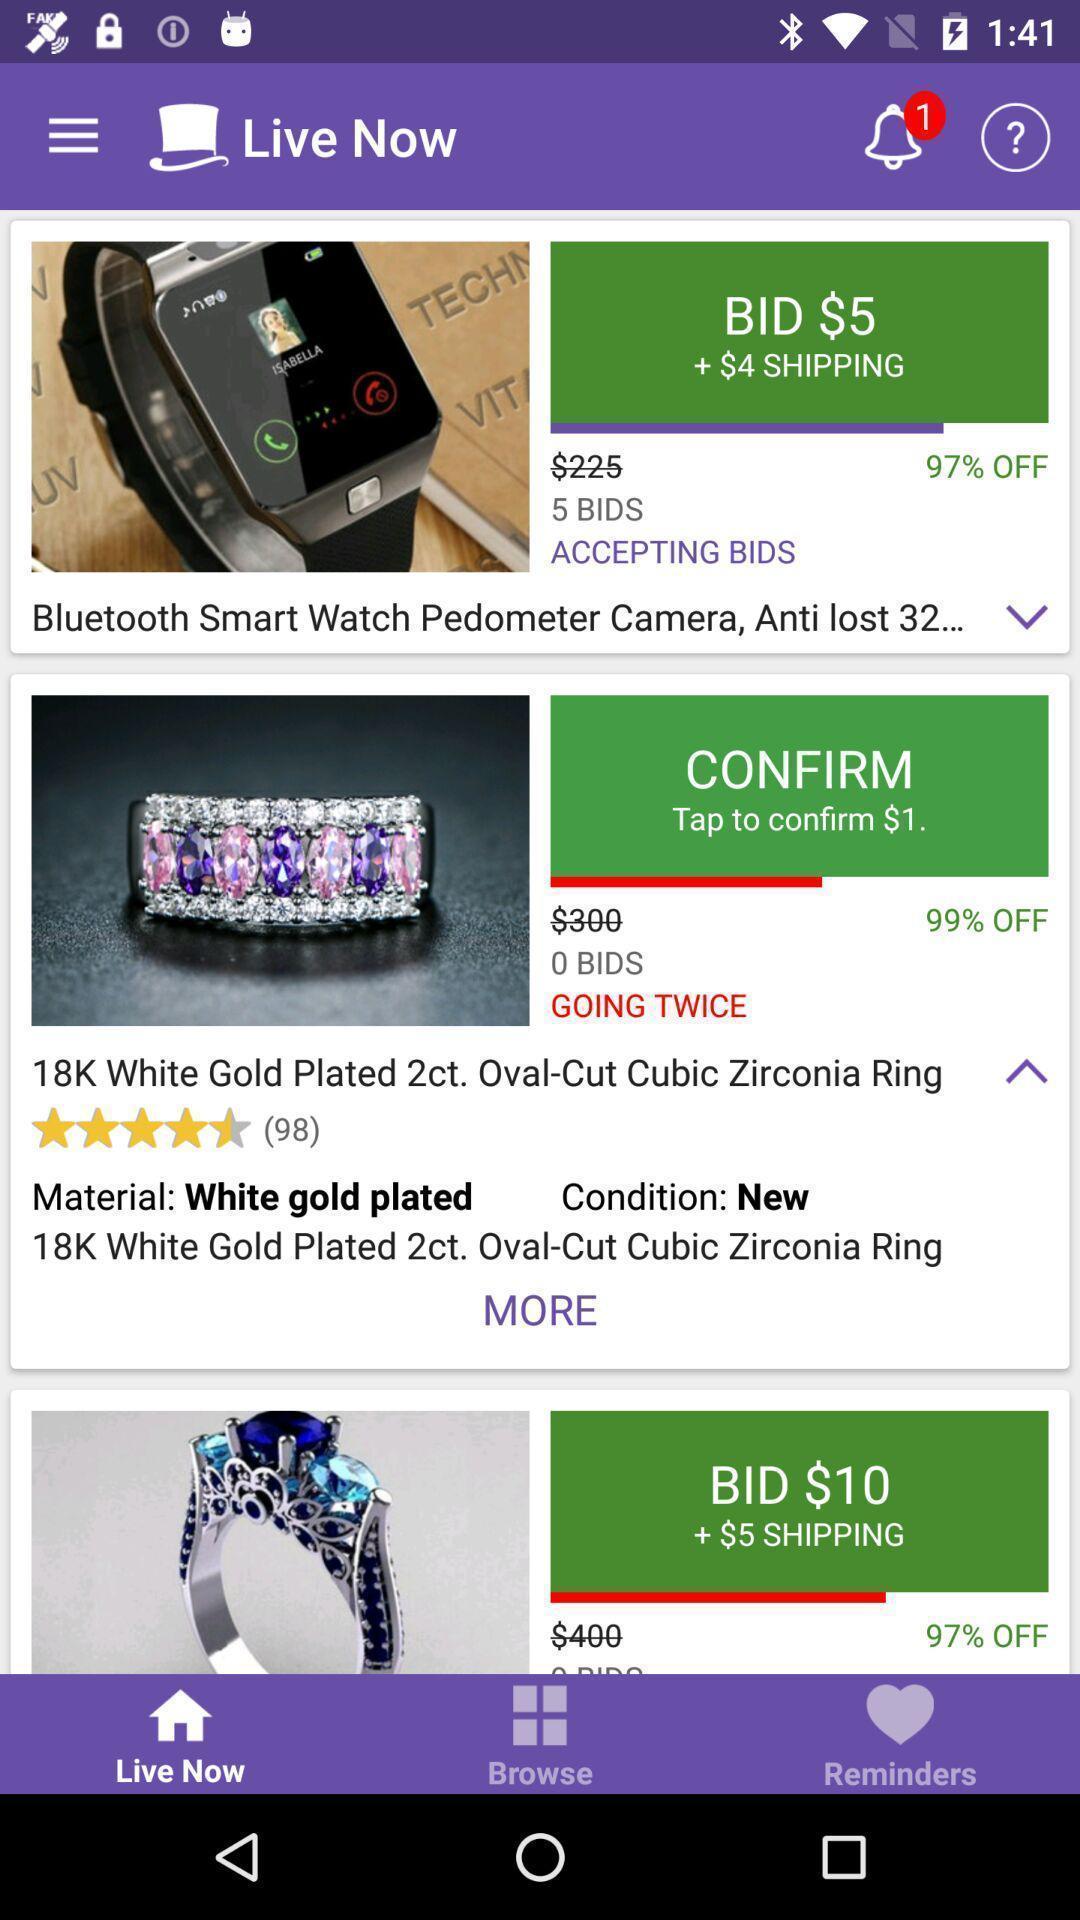Provide a detailed account of this screenshot. Page showing products from shopping app. 